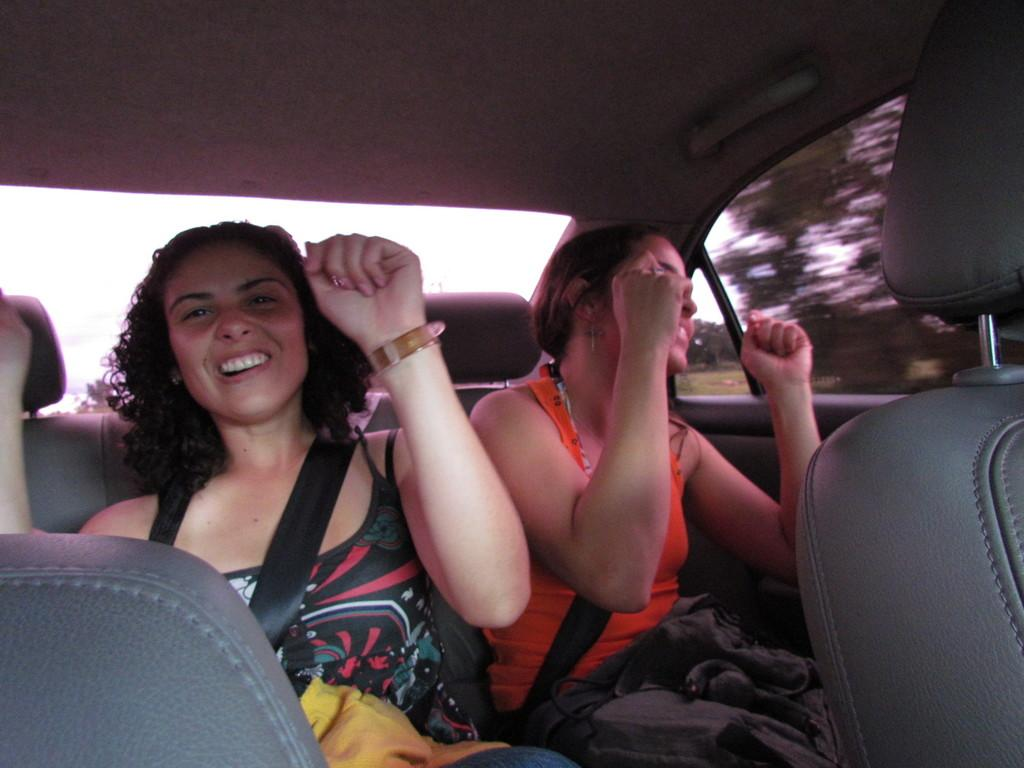What type of setting is depicted in the image? The image shows an inside view of a vehicle. Who is present in the vehicle? There are women in the vehicle. What are the women doing in the image? The women are sitting and smiling. What can be seen through the window in the background? There is a tree visible through a window in the background. What type of wax can be seen melting on the street in the image? There is no wax or street present in the image; it shows an inside view of a vehicle with women sitting and smiling. 